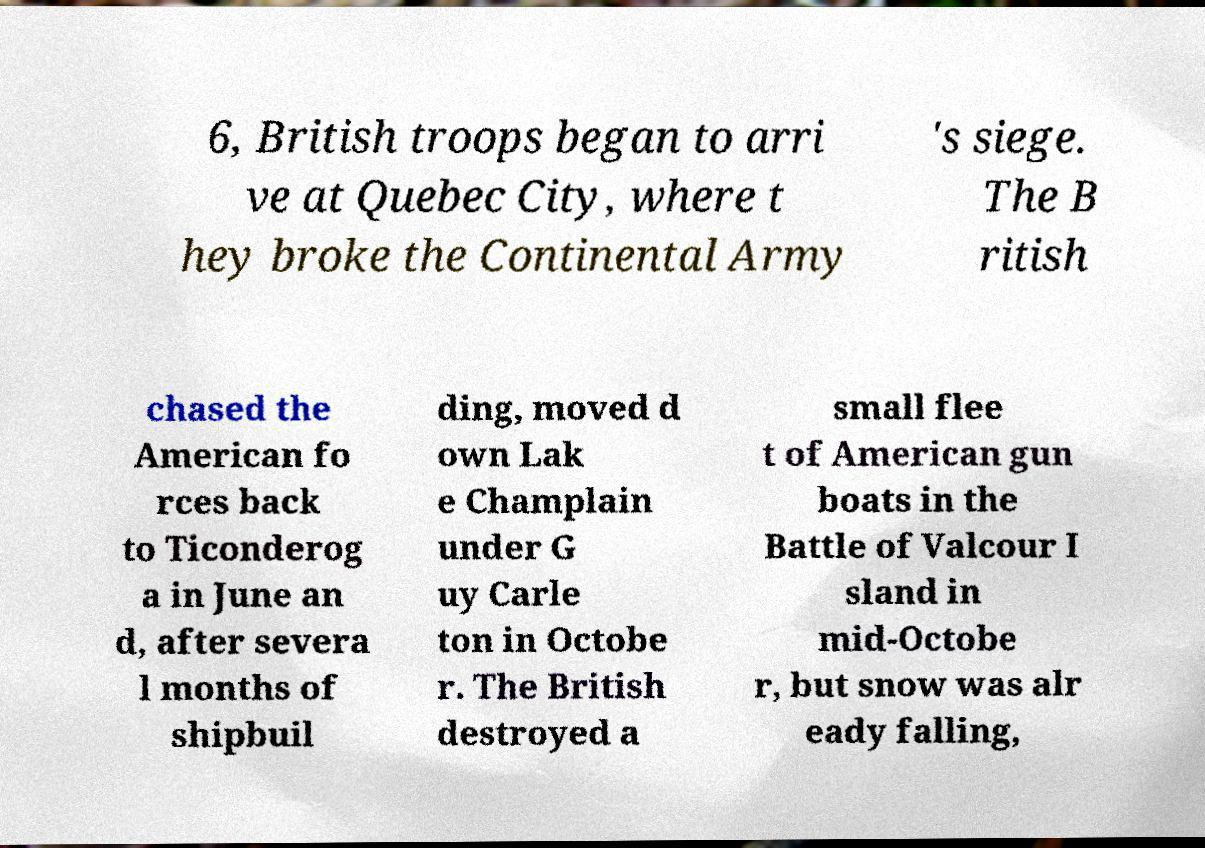Please identify and transcribe the text found in this image. 6, British troops began to arri ve at Quebec City, where t hey broke the Continental Army 's siege. The B ritish chased the American fo rces back to Ticonderog a in June an d, after severa l months of shipbuil ding, moved d own Lak e Champlain under G uy Carle ton in Octobe r. The British destroyed a small flee t of American gun boats in the Battle of Valcour I sland in mid-Octobe r, but snow was alr eady falling, 